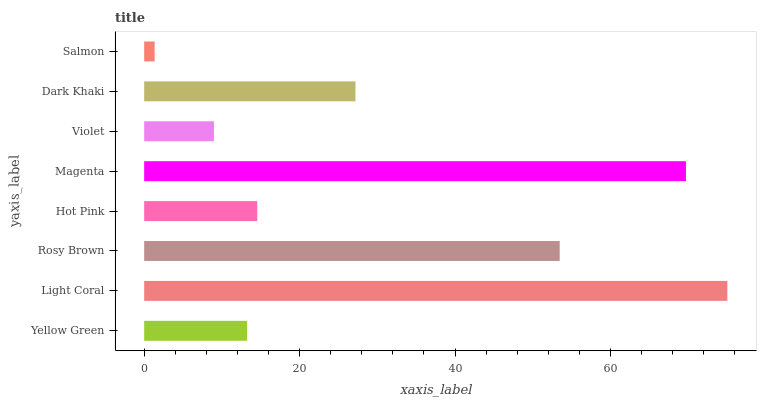Is Salmon the minimum?
Answer yes or no. Yes. Is Light Coral the maximum?
Answer yes or no. Yes. Is Rosy Brown the minimum?
Answer yes or no. No. Is Rosy Brown the maximum?
Answer yes or no. No. Is Light Coral greater than Rosy Brown?
Answer yes or no. Yes. Is Rosy Brown less than Light Coral?
Answer yes or no. Yes. Is Rosy Brown greater than Light Coral?
Answer yes or no. No. Is Light Coral less than Rosy Brown?
Answer yes or no. No. Is Dark Khaki the high median?
Answer yes or no. Yes. Is Hot Pink the low median?
Answer yes or no. Yes. Is Magenta the high median?
Answer yes or no. No. Is Magenta the low median?
Answer yes or no. No. 